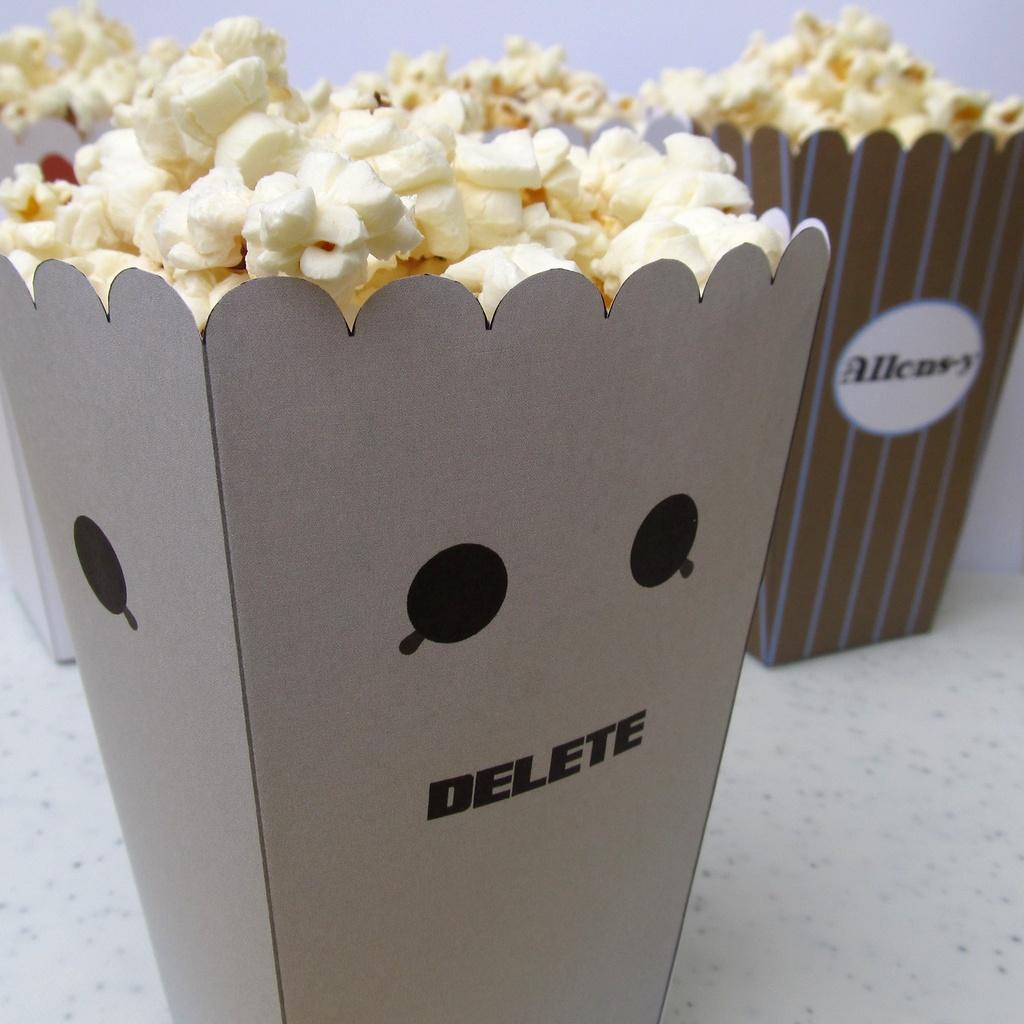How would you summarize this image in a sentence or two? In this image I can see few popcorn-buckets on the white color surface. I can see the white color background. 